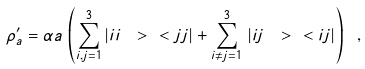<formula> <loc_0><loc_0><loc_500><loc_500>\rho ^ { \prime } _ { a } = \alpha a \, \left ( \sum _ { i , j = 1 } ^ { 3 } | i i \ > \ < j j | + \sum _ { i \neq j = 1 } ^ { 3 } \, | i j \ > \ < i j | \right ) \ ,</formula> 